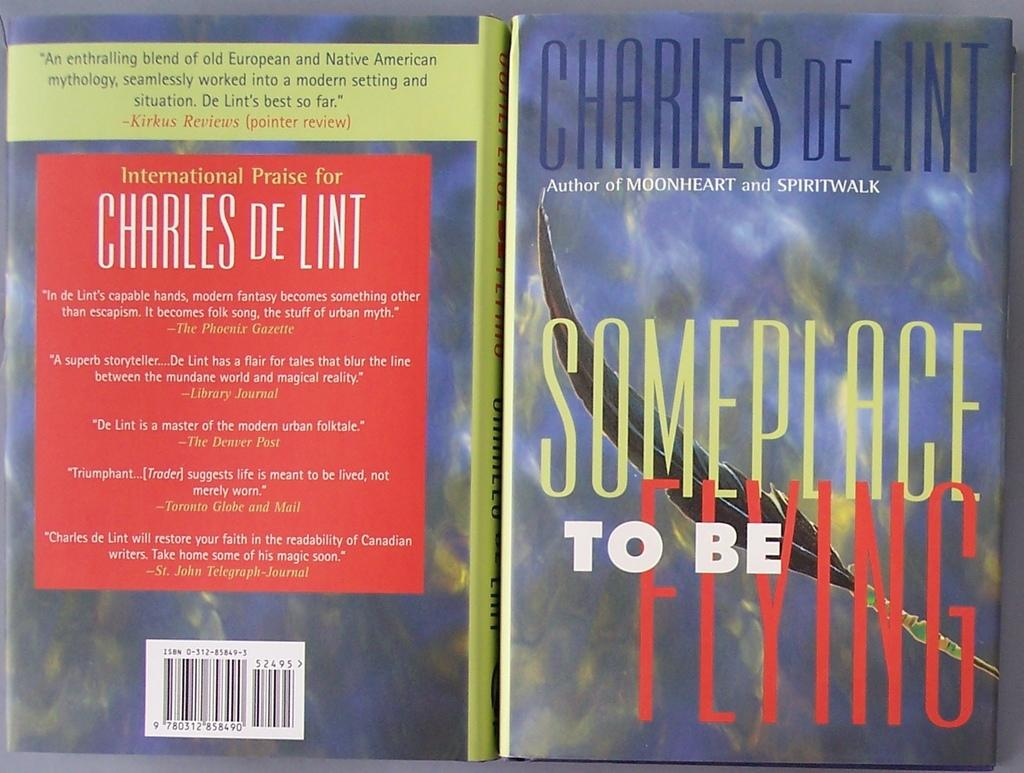<image>
Describe the image concisely. Book cover and back by Charles DeLint titled someplace to be flying 